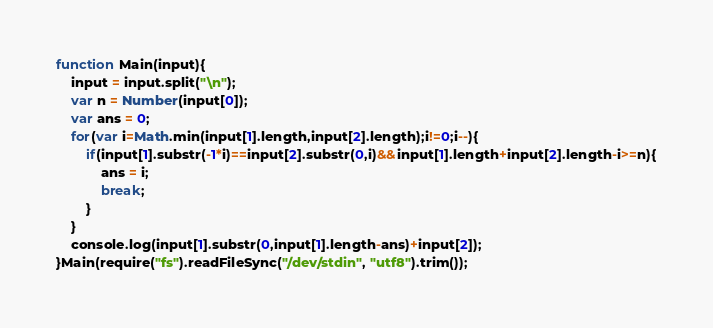Convert code to text. <code><loc_0><loc_0><loc_500><loc_500><_JavaScript_>function Main(input){
	input = input.split("\n");
	var n = Number(input[0]);
	var ans = 0;
	for(var i=Math.min(input[1].length,input[2].length);i!=0;i--){
		if(input[1].substr(-1*i)==input[2].substr(0,i)&&input[1].length+input[2].length-i>=n){
			ans = i;
			break;
		}
	}
	console.log(input[1].substr(0,input[1].length-ans)+input[2]);
}Main(require("fs").readFileSync("/dev/stdin", "utf8").trim());</code> 